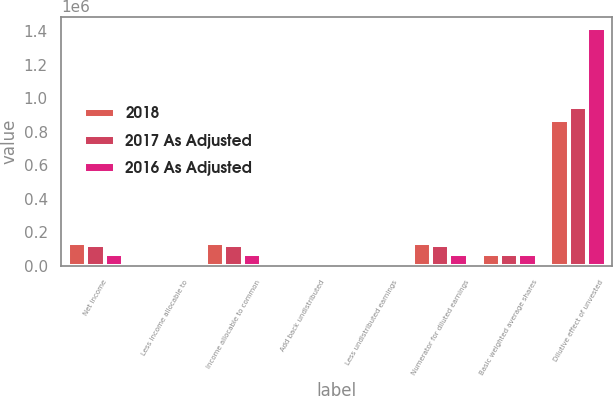<chart> <loc_0><loc_0><loc_500><loc_500><stacked_bar_chart><ecel><fcel>Net income<fcel>Less income allocable to<fcel>Income allocable to common<fcel>Add back undistributed<fcel>Less undistributed earnings<fcel>Numerator for diluted earnings<fcel>Basic weighted average shares<fcel>Dilutive effect of unvested<nl><fcel>2018<fcel>137065<fcel>159<fcel>136906<fcel>159<fcel>156<fcel>136909<fcel>69886<fcel>871171<nl><fcel>2017 As Adjusted<fcel>123486<fcel>315<fcel>123171<fcel>315<fcel>310<fcel>123176<fcel>69886<fcel>950864<nl><fcel>2016 As Adjusted<fcel>70421<fcel>535<fcel>69886<fcel>535<fcel>535<fcel>69886<fcel>69886<fcel>1.4179e+06<nl></chart> 